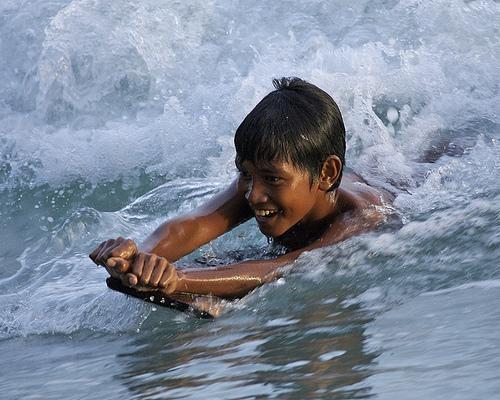How many people in picture?
Give a very brief answer. 1. 